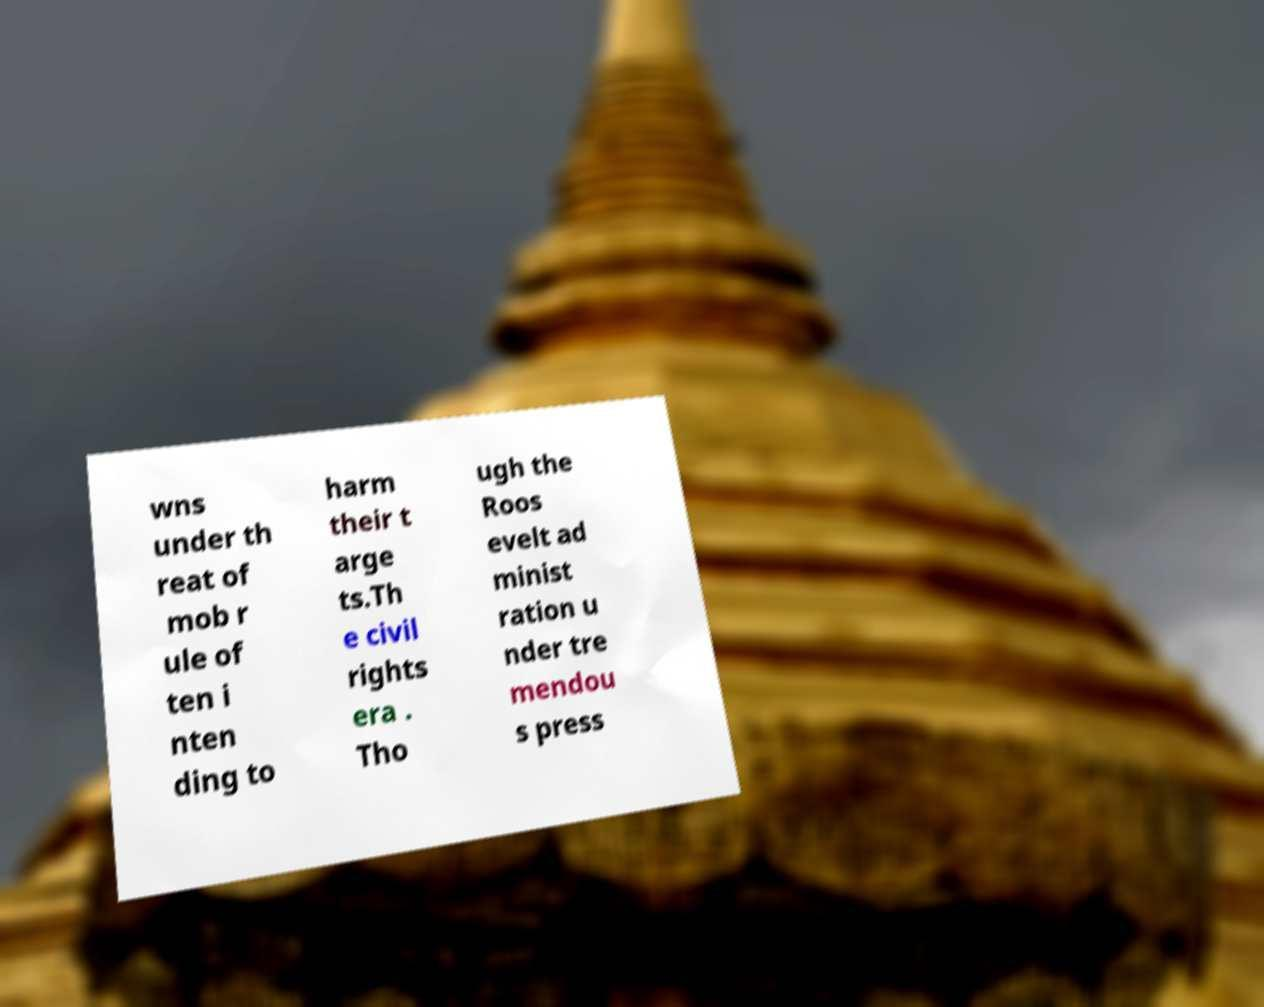Can you read and provide the text displayed in the image?This photo seems to have some interesting text. Can you extract and type it out for me? wns under th reat of mob r ule of ten i nten ding to harm their t arge ts.Th e civil rights era . Tho ugh the Roos evelt ad minist ration u nder tre mendou s press 